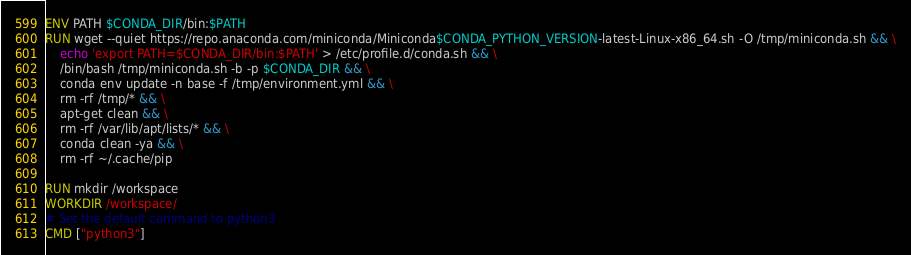<code> <loc_0><loc_0><loc_500><loc_500><_Dockerfile_>ENV PATH $CONDA_DIR/bin:$PATH
RUN wget --quiet https://repo.anaconda.com/miniconda/Miniconda$CONDA_PYTHON_VERSION-latest-Linux-x86_64.sh -O /tmp/miniconda.sh && \
    echo 'export PATH=$CONDA_DIR/bin:$PATH' > /etc/profile.d/conda.sh && \
    /bin/bash /tmp/miniconda.sh -b -p $CONDA_DIR && \
    conda env update -n base -f /tmp/environment.yml && \
    rm -rf /tmp/* && \
    apt-get clean && \
    rm -rf /var/lib/apt/lists/* && \
    conda clean -ya && \
    rm -rf ~/.cache/pip

RUN mkdir /workspace
WORKDIR /workspace/
# Set the default command to python3
CMD ["python3"]</code> 